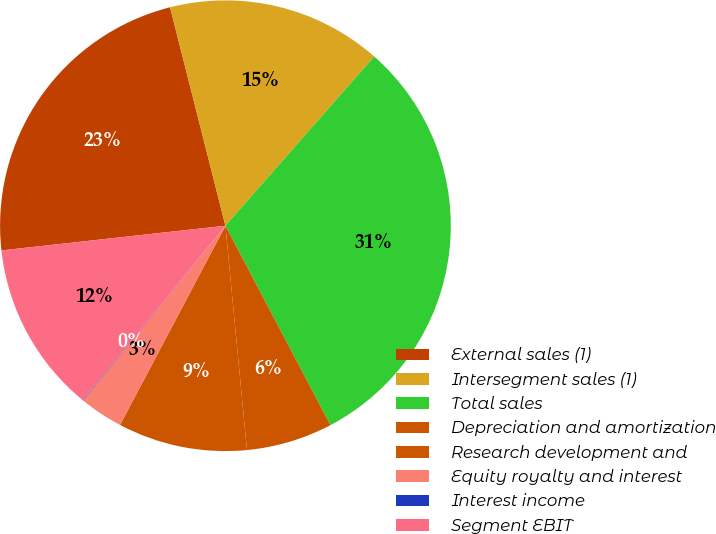Convert chart to OTSL. <chart><loc_0><loc_0><loc_500><loc_500><pie_chart><fcel>External sales (1)<fcel>Intersegment sales (1)<fcel>Total sales<fcel>Depreciation and amortization<fcel>Research development and<fcel>Equity royalty and interest<fcel>Interest income<fcel>Segment EBIT<nl><fcel>22.8%<fcel>15.43%<fcel>30.81%<fcel>6.19%<fcel>9.27%<fcel>3.12%<fcel>0.04%<fcel>12.35%<nl></chart> 